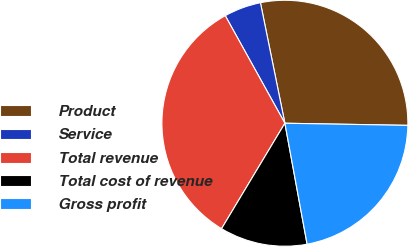Convert chart. <chart><loc_0><loc_0><loc_500><loc_500><pie_chart><fcel>Product<fcel>Service<fcel>Total revenue<fcel>Total cost of revenue<fcel>Gross profit<nl><fcel>28.46%<fcel>4.87%<fcel>33.33%<fcel>11.5%<fcel>21.83%<nl></chart> 